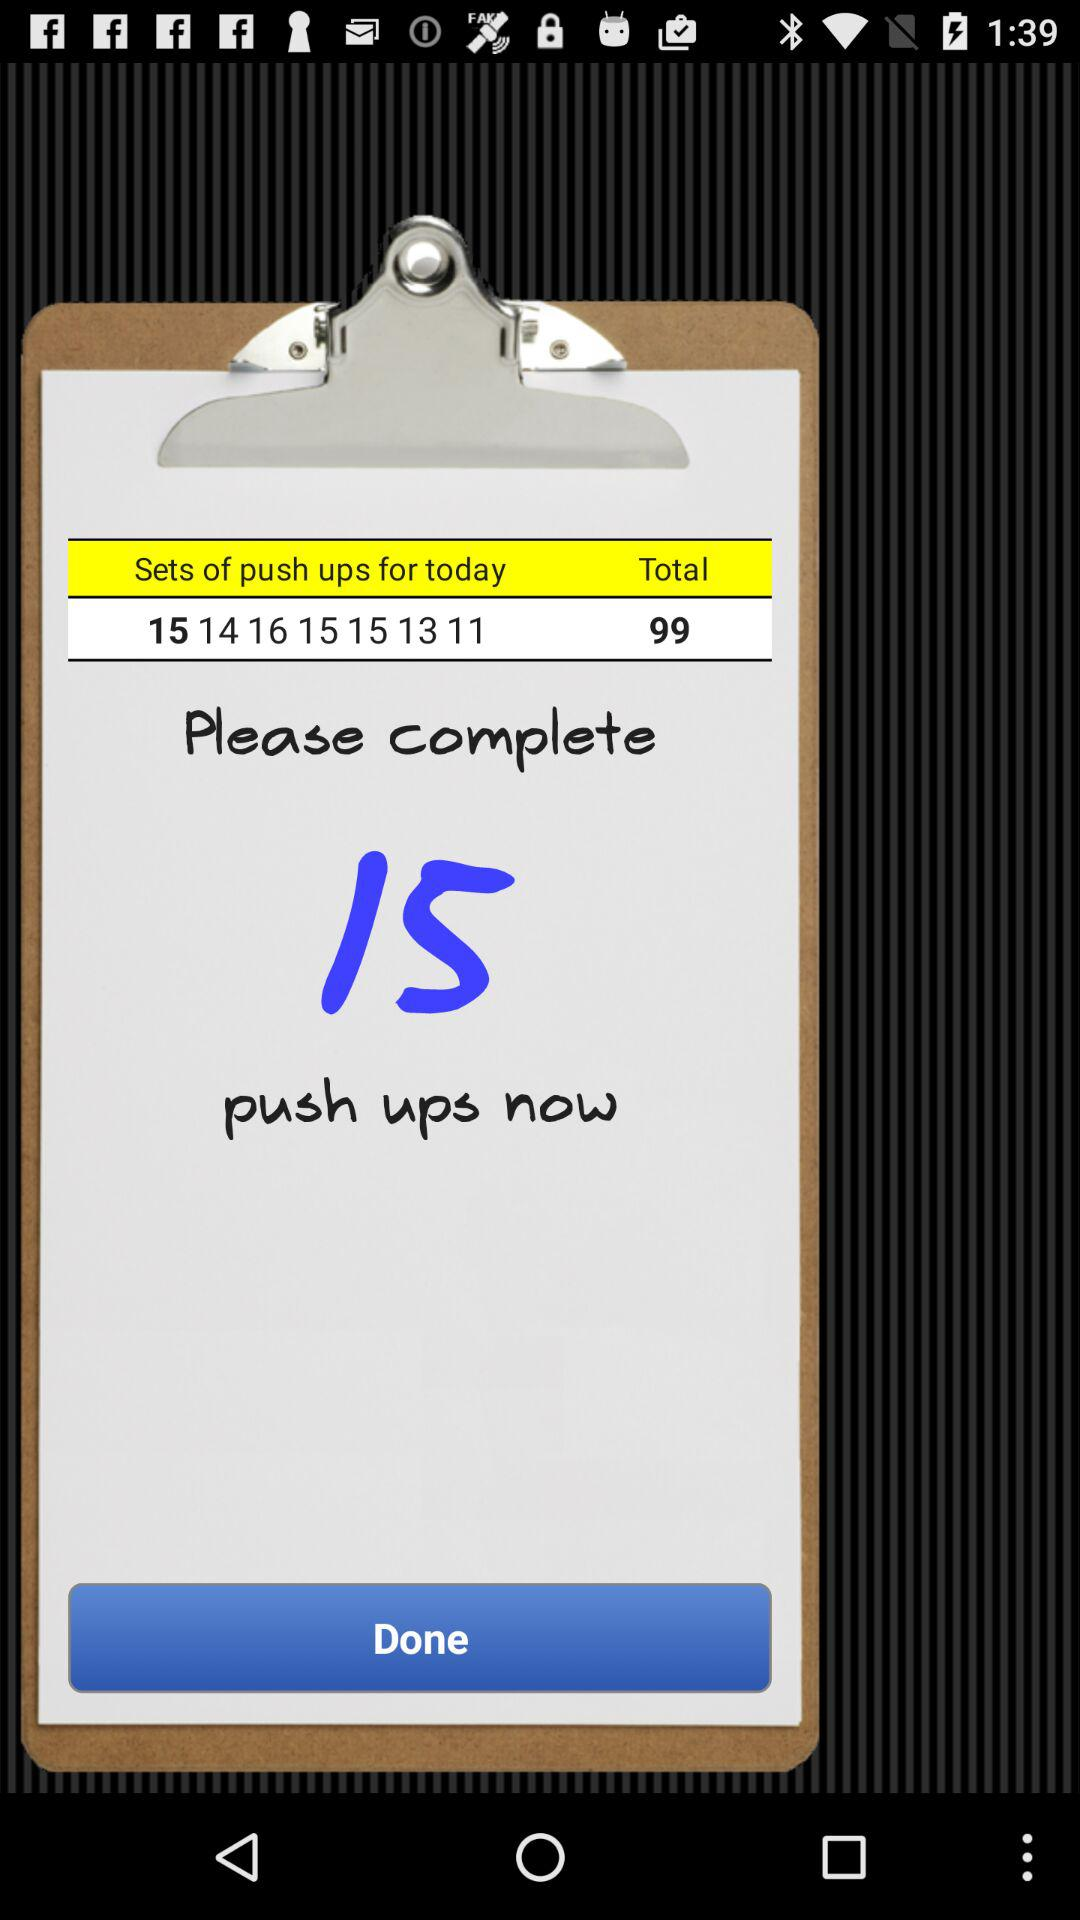How many sets of push ups are there?
Answer the question using a single word or phrase. 7 